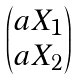<formula> <loc_0><loc_0><loc_500><loc_500>\begin{pmatrix} a X _ { 1 } \\ a X _ { 2 } \end{pmatrix}</formula> 